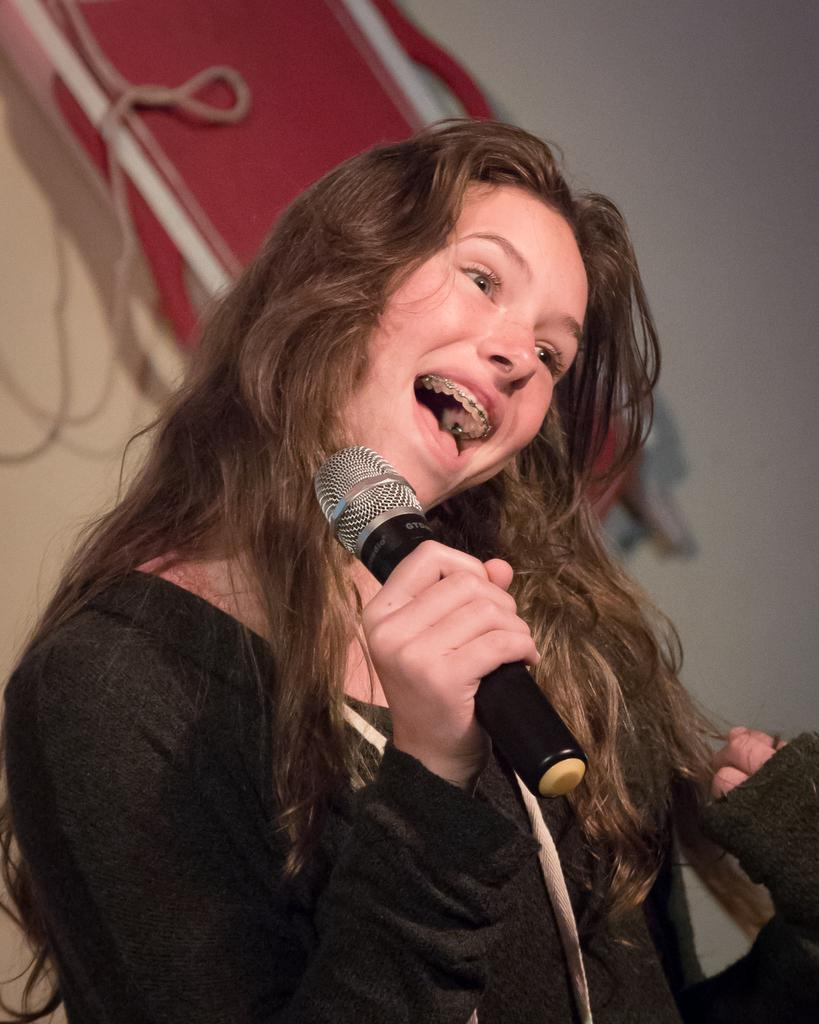Who is the main subject in the image? There is a woman in the image. What is the woman wearing? The woman is wearing a black shirt. What is the woman doing in the image? The woman is singing a song. How is the woman holding the mic? The woman is holding a mic in her right hand. What can be seen in the background of the image? There is a red color banner and a wall in the background. What type of friction is present between the woman's hand and the mic in the image? There is no information provided about the friction between the woman's hand and the mic in the image. Can you describe the ornament on the woman's head in the image? There is no ornament mentioned or visible on the woman's head in the image. 